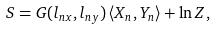Convert formula to latex. <formula><loc_0><loc_0><loc_500><loc_500>S = G ( l _ { n x } , l _ { n y } ) \left \langle X _ { n } , Y _ { n } \right \rangle + \ln Z ,</formula> 